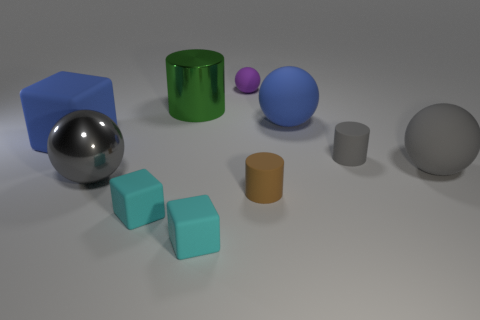There is a big blue object to the left of the tiny rubber ball; what is its shape?
Offer a terse response. Cube. Is the material of the large blue ball the same as the large gray ball that is to the right of the large metallic ball?
Provide a short and direct response. Yes. Is there a small cylinder?
Your response must be concise. Yes. Is there a tiny brown rubber object that is to the left of the metal object behind the big matte thing left of the tiny brown matte cylinder?
Make the answer very short. No. What number of big objects are either cylinders or matte cylinders?
Make the answer very short. 1. What is the color of the matte cube that is the same size as the gray shiny object?
Keep it short and to the point. Blue. How many cylinders are on the right side of the small sphere?
Provide a succinct answer. 2. Is there a cylinder that has the same material as the large green thing?
Ensure brevity in your answer.  No. What shape is the large thing that is the same color as the big matte block?
Offer a terse response. Sphere. There is a sphere that is to the left of the small matte ball; what is its color?
Keep it short and to the point. Gray. 